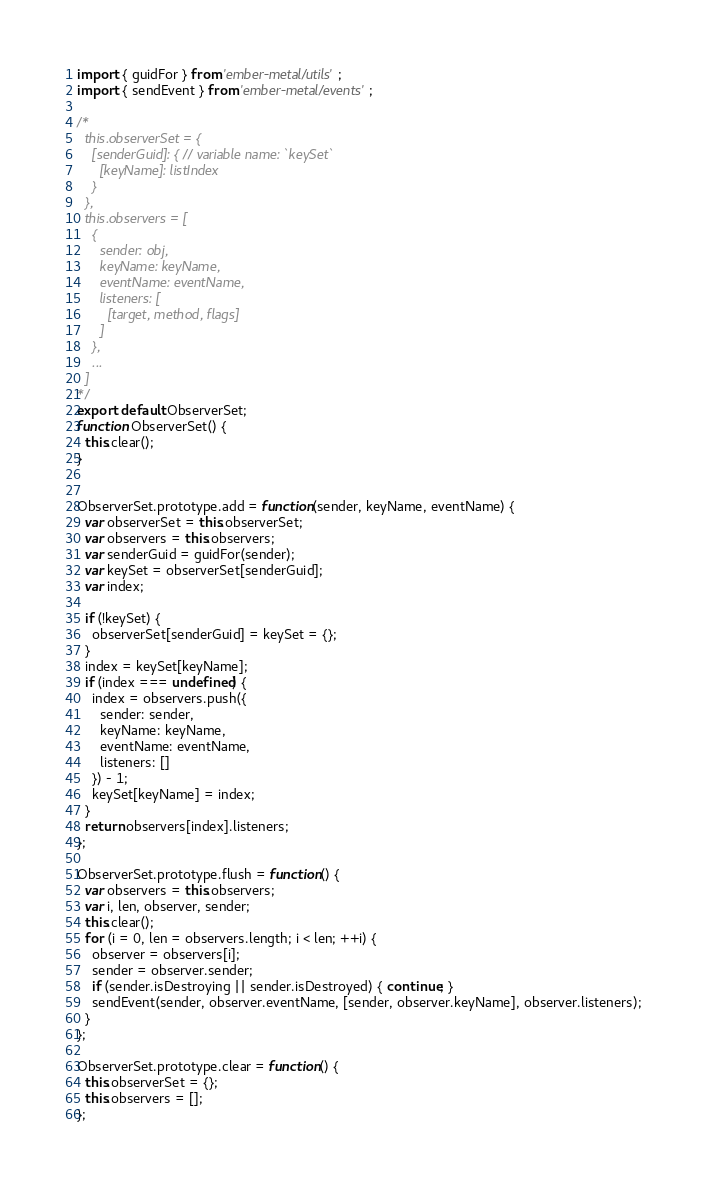<code> <loc_0><loc_0><loc_500><loc_500><_JavaScript_>import { guidFor } from 'ember-metal/utils';
import { sendEvent } from 'ember-metal/events';

/*
  this.observerSet = {
    [senderGuid]: { // variable name: `keySet`
      [keyName]: listIndex
    }
  },
  this.observers = [
    {
      sender: obj,
      keyName: keyName,
      eventName: eventName,
      listeners: [
        [target, method, flags]
      ]
    },
    ...
  ]
*/
export default ObserverSet;
function ObserverSet() {
  this.clear();
}


ObserverSet.prototype.add = function(sender, keyName, eventName) {
  var observerSet = this.observerSet;
  var observers = this.observers;
  var senderGuid = guidFor(sender);
  var keySet = observerSet[senderGuid];
  var index;

  if (!keySet) {
    observerSet[senderGuid] = keySet = {};
  }
  index = keySet[keyName];
  if (index === undefined) {
    index = observers.push({
      sender: sender,
      keyName: keyName,
      eventName: eventName,
      listeners: []
    }) - 1;
    keySet[keyName] = index;
  }
  return observers[index].listeners;
};

ObserverSet.prototype.flush = function() {
  var observers = this.observers;
  var i, len, observer, sender;
  this.clear();
  for (i = 0, len = observers.length; i < len; ++i) {
    observer = observers[i];
    sender = observer.sender;
    if (sender.isDestroying || sender.isDestroyed) { continue; }
    sendEvent(sender, observer.eventName, [sender, observer.keyName], observer.listeners);
  }
};

ObserverSet.prototype.clear = function() {
  this.observerSet = {};
  this.observers = [];
};

</code> 